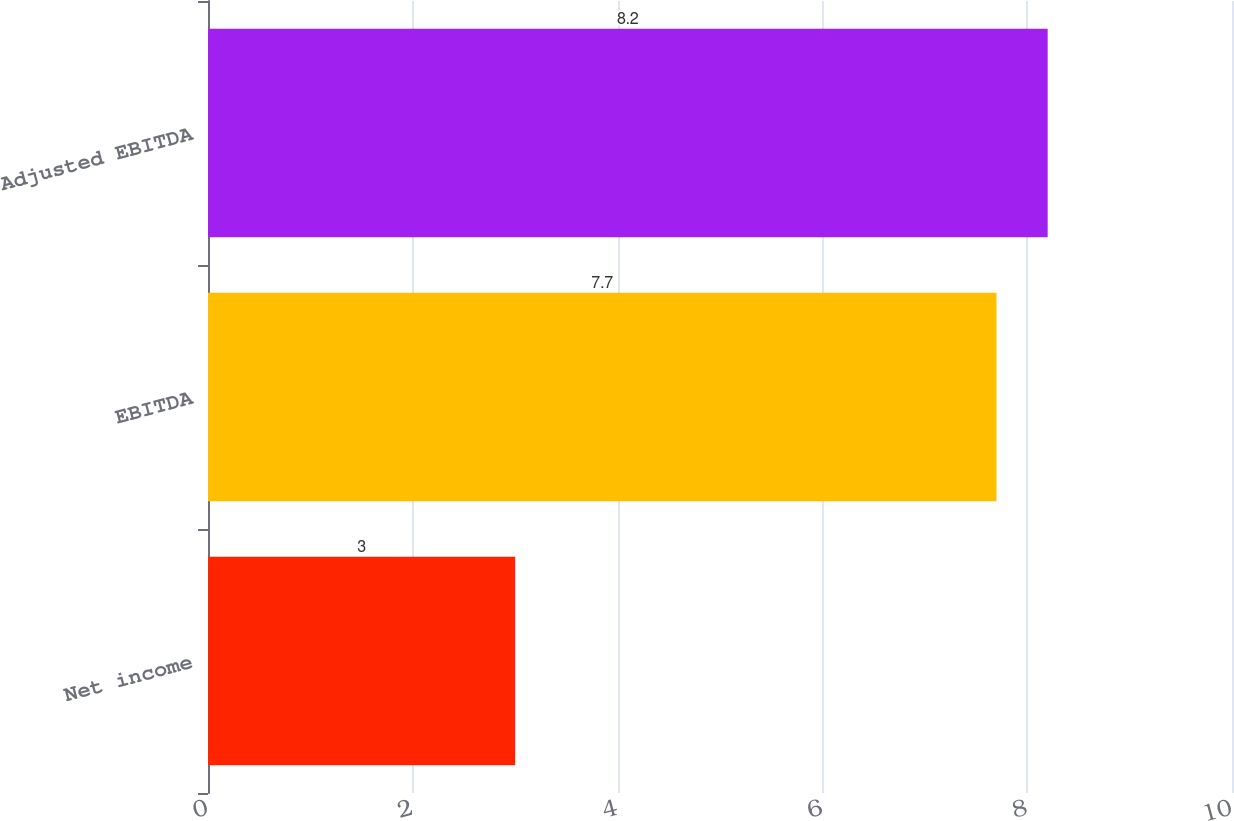<chart> <loc_0><loc_0><loc_500><loc_500><bar_chart><fcel>Net income<fcel>EBITDA<fcel>Adjusted EBITDA<nl><fcel>3<fcel>7.7<fcel>8.2<nl></chart> 